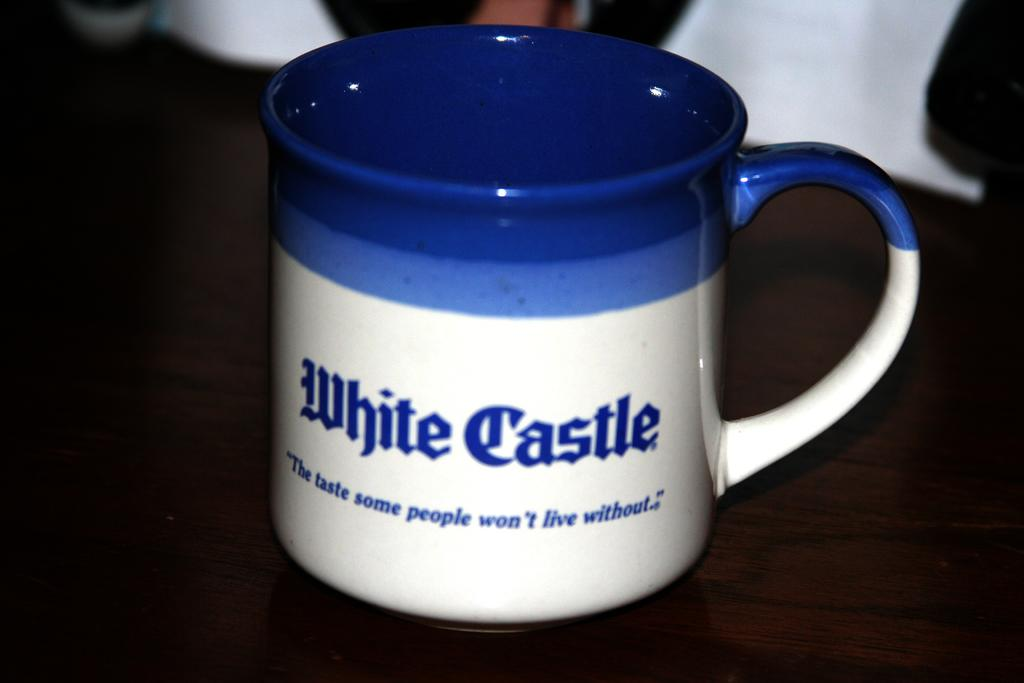<image>
Offer a succinct explanation of the picture presented. A blue and white mug has White Castle written on it in blue letters. 